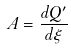<formula> <loc_0><loc_0><loc_500><loc_500>A = \frac { d Q ^ { \prime } } { d \xi }</formula> 